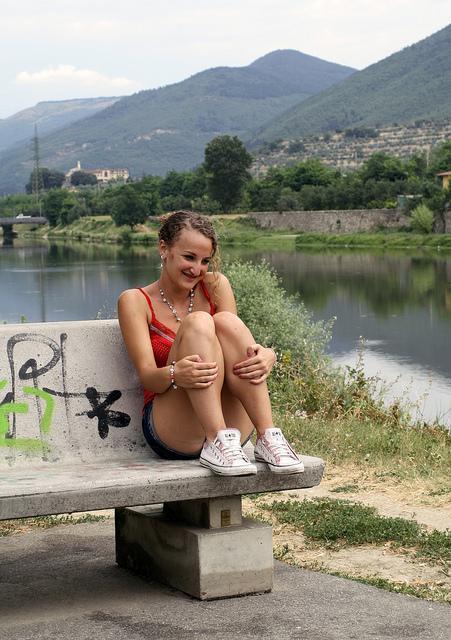How does this person feel about the photographer?
Choose the right answer from the provided options to respond to the question.
Options: Likes alot, wary, hates, spiteful. Likes alot. 